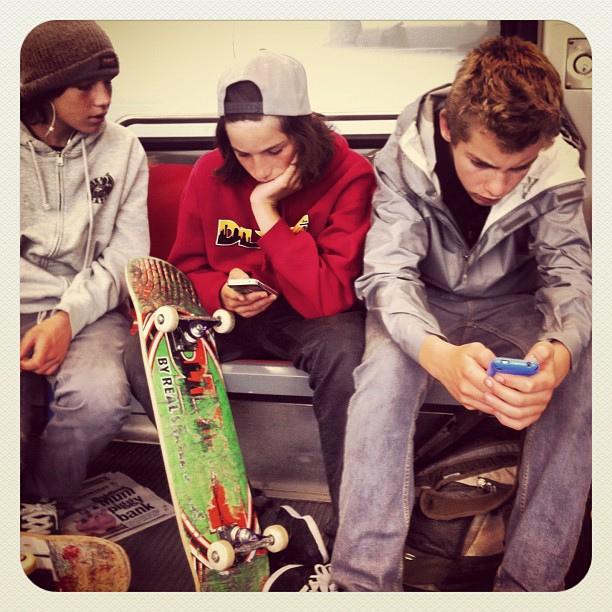What are the boys looking at?
Write a very short answer. Phones. How many people are wearing hats?
Quick response, please. 2. How many boys are looking at their cell phones?
Concise answer only. 2. 